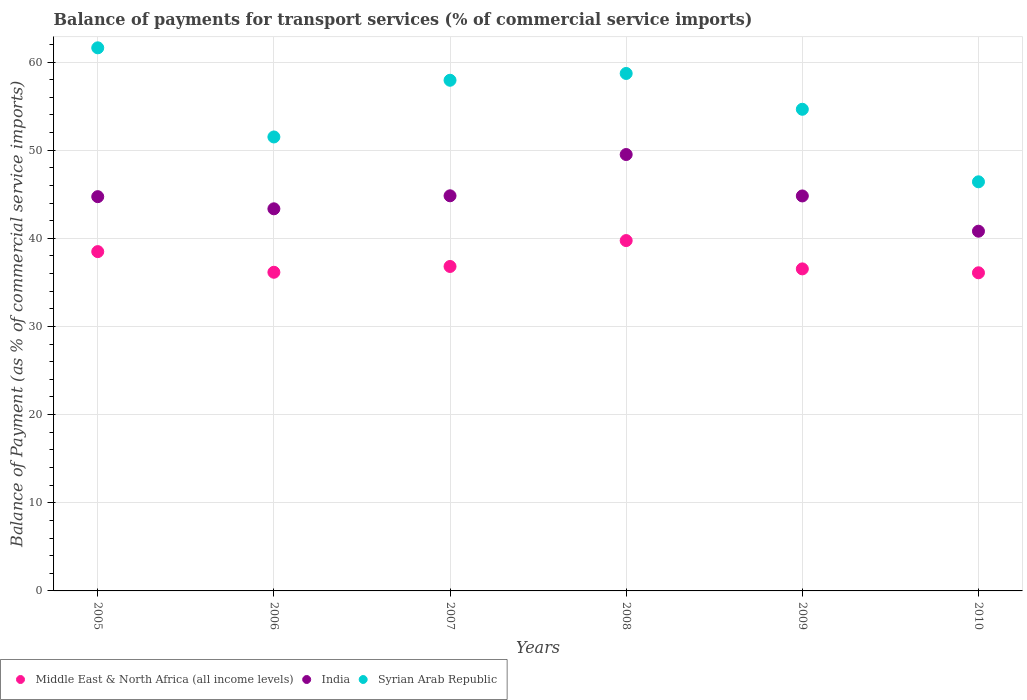How many different coloured dotlines are there?
Offer a terse response. 3. Is the number of dotlines equal to the number of legend labels?
Your answer should be compact. Yes. What is the balance of payments for transport services in Syrian Arab Republic in 2006?
Provide a succinct answer. 51.5. Across all years, what is the maximum balance of payments for transport services in Syrian Arab Republic?
Keep it short and to the point. 61.61. Across all years, what is the minimum balance of payments for transport services in Middle East & North Africa (all income levels)?
Make the answer very short. 36.09. What is the total balance of payments for transport services in India in the graph?
Offer a very short reply. 268.01. What is the difference between the balance of payments for transport services in Syrian Arab Republic in 2007 and that in 2008?
Offer a terse response. -0.77. What is the difference between the balance of payments for transport services in Middle East & North Africa (all income levels) in 2005 and the balance of payments for transport services in Syrian Arab Republic in 2007?
Make the answer very short. -19.44. What is the average balance of payments for transport services in Middle East & North Africa (all income levels) per year?
Offer a very short reply. 37.3. In the year 2005, what is the difference between the balance of payments for transport services in India and balance of payments for transport services in Middle East & North Africa (all income levels)?
Keep it short and to the point. 6.23. What is the ratio of the balance of payments for transport services in India in 2009 to that in 2010?
Ensure brevity in your answer.  1.1. Is the balance of payments for transport services in India in 2008 less than that in 2010?
Provide a short and direct response. No. What is the difference between the highest and the second highest balance of payments for transport services in Syrian Arab Republic?
Give a very brief answer. 2.91. What is the difference between the highest and the lowest balance of payments for transport services in Middle East & North Africa (all income levels)?
Your answer should be very brief. 3.65. In how many years, is the balance of payments for transport services in Syrian Arab Republic greater than the average balance of payments for transport services in Syrian Arab Republic taken over all years?
Keep it short and to the point. 3. Is the sum of the balance of payments for transport services in Middle East & North Africa (all income levels) in 2009 and 2010 greater than the maximum balance of payments for transport services in India across all years?
Your answer should be very brief. Yes. Is the balance of payments for transport services in India strictly greater than the balance of payments for transport services in Middle East & North Africa (all income levels) over the years?
Your response must be concise. Yes. Is the balance of payments for transport services in India strictly less than the balance of payments for transport services in Syrian Arab Republic over the years?
Ensure brevity in your answer.  Yes. How many dotlines are there?
Your answer should be very brief. 3. What is the difference between two consecutive major ticks on the Y-axis?
Your answer should be very brief. 10. Where does the legend appear in the graph?
Give a very brief answer. Bottom left. How many legend labels are there?
Keep it short and to the point. 3. What is the title of the graph?
Give a very brief answer. Balance of payments for transport services (% of commercial service imports). What is the label or title of the Y-axis?
Your answer should be very brief. Balance of Payment (as % of commercial service imports). What is the Balance of Payment (as % of commercial service imports) of Middle East & North Africa (all income levels) in 2005?
Ensure brevity in your answer.  38.49. What is the Balance of Payment (as % of commercial service imports) of India in 2005?
Offer a terse response. 44.73. What is the Balance of Payment (as % of commercial service imports) in Syrian Arab Republic in 2005?
Make the answer very short. 61.61. What is the Balance of Payment (as % of commercial service imports) of Middle East & North Africa (all income levels) in 2006?
Offer a very short reply. 36.15. What is the Balance of Payment (as % of commercial service imports) in India in 2006?
Your answer should be very brief. 43.35. What is the Balance of Payment (as % of commercial service imports) of Syrian Arab Republic in 2006?
Make the answer very short. 51.5. What is the Balance of Payment (as % of commercial service imports) of Middle East & North Africa (all income levels) in 2007?
Make the answer very short. 36.81. What is the Balance of Payment (as % of commercial service imports) in India in 2007?
Your response must be concise. 44.82. What is the Balance of Payment (as % of commercial service imports) of Syrian Arab Republic in 2007?
Your response must be concise. 57.93. What is the Balance of Payment (as % of commercial service imports) of Middle East & North Africa (all income levels) in 2008?
Ensure brevity in your answer.  39.74. What is the Balance of Payment (as % of commercial service imports) in India in 2008?
Keep it short and to the point. 49.51. What is the Balance of Payment (as % of commercial service imports) in Syrian Arab Republic in 2008?
Ensure brevity in your answer.  58.7. What is the Balance of Payment (as % of commercial service imports) in Middle East & North Africa (all income levels) in 2009?
Your response must be concise. 36.53. What is the Balance of Payment (as % of commercial service imports) of India in 2009?
Offer a very short reply. 44.81. What is the Balance of Payment (as % of commercial service imports) in Syrian Arab Republic in 2009?
Keep it short and to the point. 54.64. What is the Balance of Payment (as % of commercial service imports) of Middle East & North Africa (all income levels) in 2010?
Provide a short and direct response. 36.09. What is the Balance of Payment (as % of commercial service imports) of India in 2010?
Offer a terse response. 40.81. What is the Balance of Payment (as % of commercial service imports) of Syrian Arab Republic in 2010?
Make the answer very short. 46.41. Across all years, what is the maximum Balance of Payment (as % of commercial service imports) of Middle East & North Africa (all income levels)?
Keep it short and to the point. 39.74. Across all years, what is the maximum Balance of Payment (as % of commercial service imports) of India?
Your answer should be compact. 49.51. Across all years, what is the maximum Balance of Payment (as % of commercial service imports) in Syrian Arab Republic?
Give a very brief answer. 61.61. Across all years, what is the minimum Balance of Payment (as % of commercial service imports) in Middle East & North Africa (all income levels)?
Provide a short and direct response. 36.09. Across all years, what is the minimum Balance of Payment (as % of commercial service imports) in India?
Your answer should be compact. 40.81. Across all years, what is the minimum Balance of Payment (as % of commercial service imports) in Syrian Arab Republic?
Your response must be concise. 46.41. What is the total Balance of Payment (as % of commercial service imports) of Middle East & North Africa (all income levels) in the graph?
Your response must be concise. 223.81. What is the total Balance of Payment (as % of commercial service imports) in India in the graph?
Your answer should be very brief. 268.01. What is the total Balance of Payment (as % of commercial service imports) in Syrian Arab Republic in the graph?
Keep it short and to the point. 330.79. What is the difference between the Balance of Payment (as % of commercial service imports) of Middle East & North Africa (all income levels) in 2005 and that in 2006?
Your response must be concise. 2.34. What is the difference between the Balance of Payment (as % of commercial service imports) in India in 2005 and that in 2006?
Offer a terse response. 1.38. What is the difference between the Balance of Payment (as % of commercial service imports) in Syrian Arab Republic in 2005 and that in 2006?
Offer a terse response. 10.11. What is the difference between the Balance of Payment (as % of commercial service imports) in Middle East & North Africa (all income levels) in 2005 and that in 2007?
Give a very brief answer. 1.68. What is the difference between the Balance of Payment (as % of commercial service imports) of India in 2005 and that in 2007?
Offer a very short reply. -0.1. What is the difference between the Balance of Payment (as % of commercial service imports) in Syrian Arab Republic in 2005 and that in 2007?
Keep it short and to the point. 3.68. What is the difference between the Balance of Payment (as % of commercial service imports) in Middle East & North Africa (all income levels) in 2005 and that in 2008?
Provide a short and direct response. -1.25. What is the difference between the Balance of Payment (as % of commercial service imports) of India in 2005 and that in 2008?
Your response must be concise. -4.78. What is the difference between the Balance of Payment (as % of commercial service imports) in Syrian Arab Republic in 2005 and that in 2008?
Your answer should be very brief. 2.91. What is the difference between the Balance of Payment (as % of commercial service imports) in Middle East & North Africa (all income levels) in 2005 and that in 2009?
Keep it short and to the point. 1.96. What is the difference between the Balance of Payment (as % of commercial service imports) of India in 2005 and that in 2009?
Give a very brief answer. -0.08. What is the difference between the Balance of Payment (as % of commercial service imports) of Syrian Arab Republic in 2005 and that in 2009?
Give a very brief answer. 6.97. What is the difference between the Balance of Payment (as % of commercial service imports) of Middle East & North Africa (all income levels) in 2005 and that in 2010?
Your response must be concise. 2.4. What is the difference between the Balance of Payment (as % of commercial service imports) in India in 2005 and that in 2010?
Keep it short and to the point. 3.92. What is the difference between the Balance of Payment (as % of commercial service imports) in Syrian Arab Republic in 2005 and that in 2010?
Make the answer very short. 15.2. What is the difference between the Balance of Payment (as % of commercial service imports) in Middle East & North Africa (all income levels) in 2006 and that in 2007?
Keep it short and to the point. -0.66. What is the difference between the Balance of Payment (as % of commercial service imports) of India in 2006 and that in 2007?
Give a very brief answer. -1.48. What is the difference between the Balance of Payment (as % of commercial service imports) of Syrian Arab Republic in 2006 and that in 2007?
Keep it short and to the point. -6.43. What is the difference between the Balance of Payment (as % of commercial service imports) in Middle East & North Africa (all income levels) in 2006 and that in 2008?
Give a very brief answer. -3.6. What is the difference between the Balance of Payment (as % of commercial service imports) of India in 2006 and that in 2008?
Your response must be concise. -6.16. What is the difference between the Balance of Payment (as % of commercial service imports) in Syrian Arab Republic in 2006 and that in 2008?
Give a very brief answer. -7.2. What is the difference between the Balance of Payment (as % of commercial service imports) in Middle East & North Africa (all income levels) in 2006 and that in 2009?
Offer a terse response. -0.38. What is the difference between the Balance of Payment (as % of commercial service imports) of India in 2006 and that in 2009?
Keep it short and to the point. -1.46. What is the difference between the Balance of Payment (as % of commercial service imports) in Syrian Arab Republic in 2006 and that in 2009?
Keep it short and to the point. -3.14. What is the difference between the Balance of Payment (as % of commercial service imports) of Middle East & North Africa (all income levels) in 2006 and that in 2010?
Ensure brevity in your answer.  0.06. What is the difference between the Balance of Payment (as % of commercial service imports) in India in 2006 and that in 2010?
Your answer should be compact. 2.54. What is the difference between the Balance of Payment (as % of commercial service imports) of Syrian Arab Republic in 2006 and that in 2010?
Offer a terse response. 5.09. What is the difference between the Balance of Payment (as % of commercial service imports) in Middle East & North Africa (all income levels) in 2007 and that in 2008?
Provide a short and direct response. -2.94. What is the difference between the Balance of Payment (as % of commercial service imports) in India in 2007 and that in 2008?
Offer a very short reply. -4.68. What is the difference between the Balance of Payment (as % of commercial service imports) of Syrian Arab Republic in 2007 and that in 2008?
Ensure brevity in your answer.  -0.77. What is the difference between the Balance of Payment (as % of commercial service imports) of Middle East & North Africa (all income levels) in 2007 and that in 2009?
Make the answer very short. 0.27. What is the difference between the Balance of Payment (as % of commercial service imports) of India in 2007 and that in 2009?
Your response must be concise. 0.02. What is the difference between the Balance of Payment (as % of commercial service imports) in Syrian Arab Republic in 2007 and that in 2009?
Offer a very short reply. 3.29. What is the difference between the Balance of Payment (as % of commercial service imports) of Middle East & North Africa (all income levels) in 2007 and that in 2010?
Ensure brevity in your answer.  0.72. What is the difference between the Balance of Payment (as % of commercial service imports) of India in 2007 and that in 2010?
Ensure brevity in your answer.  4.02. What is the difference between the Balance of Payment (as % of commercial service imports) of Syrian Arab Republic in 2007 and that in 2010?
Ensure brevity in your answer.  11.52. What is the difference between the Balance of Payment (as % of commercial service imports) of Middle East & North Africa (all income levels) in 2008 and that in 2009?
Provide a short and direct response. 3.21. What is the difference between the Balance of Payment (as % of commercial service imports) of India in 2008 and that in 2009?
Make the answer very short. 4.7. What is the difference between the Balance of Payment (as % of commercial service imports) in Syrian Arab Republic in 2008 and that in 2009?
Make the answer very short. 4.06. What is the difference between the Balance of Payment (as % of commercial service imports) in Middle East & North Africa (all income levels) in 2008 and that in 2010?
Your answer should be very brief. 3.65. What is the difference between the Balance of Payment (as % of commercial service imports) in India in 2008 and that in 2010?
Ensure brevity in your answer.  8.7. What is the difference between the Balance of Payment (as % of commercial service imports) of Syrian Arab Republic in 2008 and that in 2010?
Keep it short and to the point. 12.29. What is the difference between the Balance of Payment (as % of commercial service imports) in Middle East & North Africa (all income levels) in 2009 and that in 2010?
Offer a very short reply. 0.44. What is the difference between the Balance of Payment (as % of commercial service imports) of India in 2009 and that in 2010?
Your response must be concise. 4. What is the difference between the Balance of Payment (as % of commercial service imports) of Syrian Arab Republic in 2009 and that in 2010?
Ensure brevity in your answer.  8.23. What is the difference between the Balance of Payment (as % of commercial service imports) in Middle East & North Africa (all income levels) in 2005 and the Balance of Payment (as % of commercial service imports) in India in 2006?
Offer a terse response. -4.86. What is the difference between the Balance of Payment (as % of commercial service imports) of Middle East & North Africa (all income levels) in 2005 and the Balance of Payment (as % of commercial service imports) of Syrian Arab Republic in 2006?
Give a very brief answer. -13.01. What is the difference between the Balance of Payment (as % of commercial service imports) in India in 2005 and the Balance of Payment (as % of commercial service imports) in Syrian Arab Republic in 2006?
Make the answer very short. -6.77. What is the difference between the Balance of Payment (as % of commercial service imports) of Middle East & North Africa (all income levels) in 2005 and the Balance of Payment (as % of commercial service imports) of India in 2007?
Provide a short and direct response. -6.33. What is the difference between the Balance of Payment (as % of commercial service imports) in Middle East & North Africa (all income levels) in 2005 and the Balance of Payment (as % of commercial service imports) in Syrian Arab Republic in 2007?
Your response must be concise. -19.44. What is the difference between the Balance of Payment (as % of commercial service imports) in India in 2005 and the Balance of Payment (as % of commercial service imports) in Syrian Arab Republic in 2007?
Provide a short and direct response. -13.2. What is the difference between the Balance of Payment (as % of commercial service imports) in Middle East & North Africa (all income levels) in 2005 and the Balance of Payment (as % of commercial service imports) in India in 2008?
Provide a short and direct response. -11.01. What is the difference between the Balance of Payment (as % of commercial service imports) of Middle East & North Africa (all income levels) in 2005 and the Balance of Payment (as % of commercial service imports) of Syrian Arab Republic in 2008?
Provide a succinct answer. -20.21. What is the difference between the Balance of Payment (as % of commercial service imports) in India in 2005 and the Balance of Payment (as % of commercial service imports) in Syrian Arab Republic in 2008?
Provide a short and direct response. -13.98. What is the difference between the Balance of Payment (as % of commercial service imports) of Middle East & North Africa (all income levels) in 2005 and the Balance of Payment (as % of commercial service imports) of India in 2009?
Provide a short and direct response. -6.31. What is the difference between the Balance of Payment (as % of commercial service imports) of Middle East & North Africa (all income levels) in 2005 and the Balance of Payment (as % of commercial service imports) of Syrian Arab Republic in 2009?
Your answer should be compact. -16.15. What is the difference between the Balance of Payment (as % of commercial service imports) in India in 2005 and the Balance of Payment (as % of commercial service imports) in Syrian Arab Republic in 2009?
Keep it short and to the point. -9.91. What is the difference between the Balance of Payment (as % of commercial service imports) in Middle East & North Africa (all income levels) in 2005 and the Balance of Payment (as % of commercial service imports) in India in 2010?
Make the answer very short. -2.32. What is the difference between the Balance of Payment (as % of commercial service imports) of Middle East & North Africa (all income levels) in 2005 and the Balance of Payment (as % of commercial service imports) of Syrian Arab Republic in 2010?
Your answer should be very brief. -7.92. What is the difference between the Balance of Payment (as % of commercial service imports) in India in 2005 and the Balance of Payment (as % of commercial service imports) in Syrian Arab Republic in 2010?
Make the answer very short. -1.68. What is the difference between the Balance of Payment (as % of commercial service imports) in Middle East & North Africa (all income levels) in 2006 and the Balance of Payment (as % of commercial service imports) in India in 2007?
Give a very brief answer. -8.67. What is the difference between the Balance of Payment (as % of commercial service imports) in Middle East & North Africa (all income levels) in 2006 and the Balance of Payment (as % of commercial service imports) in Syrian Arab Republic in 2007?
Offer a very short reply. -21.78. What is the difference between the Balance of Payment (as % of commercial service imports) in India in 2006 and the Balance of Payment (as % of commercial service imports) in Syrian Arab Republic in 2007?
Make the answer very short. -14.58. What is the difference between the Balance of Payment (as % of commercial service imports) in Middle East & North Africa (all income levels) in 2006 and the Balance of Payment (as % of commercial service imports) in India in 2008?
Provide a succinct answer. -13.36. What is the difference between the Balance of Payment (as % of commercial service imports) of Middle East & North Africa (all income levels) in 2006 and the Balance of Payment (as % of commercial service imports) of Syrian Arab Republic in 2008?
Your response must be concise. -22.55. What is the difference between the Balance of Payment (as % of commercial service imports) in India in 2006 and the Balance of Payment (as % of commercial service imports) in Syrian Arab Republic in 2008?
Ensure brevity in your answer.  -15.35. What is the difference between the Balance of Payment (as % of commercial service imports) of Middle East & North Africa (all income levels) in 2006 and the Balance of Payment (as % of commercial service imports) of India in 2009?
Keep it short and to the point. -8.66. What is the difference between the Balance of Payment (as % of commercial service imports) in Middle East & North Africa (all income levels) in 2006 and the Balance of Payment (as % of commercial service imports) in Syrian Arab Republic in 2009?
Make the answer very short. -18.49. What is the difference between the Balance of Payment (as % of commercial service imports) of India in 2006 and the Balance of Payment (as % of commercial service imports) of Syrian Arab Republic in 2009?
Make the answer very short. -11.29. What is the difference between the Balance of Payment (as % of commercial service imports) in Middle East & North Africa (all income levels) in 2006 and the Balance of Payment (as % of commercial service imports) in India in 2010?
Keep it short and to the point. -4.66. What is the difference between the Balance of Payment (as % of commercial service imports) of Middle East & North Africa (all income levels) in 2006 and the Balance of Payment (as % of commercial service imports) of Syrian Arab Republic in 2010?
Make the answer very short. -10.26. What is the difference between the Balance of Payment (as % of commercial service imports) in India in 2006 and the Balance of Payment (as % of commercial service imports) in Syrian Arab Republic in 2010?
Your response must be concise. -3.06. What is the difference between the Balance of Payment (as % of commercial service imports) of Middle East & North Africa (all income levels) in 2007 and the Balance of Payment (as % of commercial service imports) of India in 2008?
Ensure brevity in your answer.  -12.7. What is the difference between the Balance of Payment (as % of commercial service imports) in Middle East & North Africa (all income levels) in 2007 and the Balance of Payment (as % of commercial service imports) in Syrian Arab Republic in 2008?
Provide a succinct answer. -21.89. What is the difference between the Balance of Payment (as % of commercial service imports) in India in 2007 and the Balance of Payment (as % of commercial service imports) in Syrian Arab Republic in 2008?
Make the answer very short. -13.88. What is the difference between the Balance of Payment (as % of commercial service imports) of Middle East & North Africa (all income levels) in 2007 and the Balance of Payment (as % of commercial service imports) of India in 2009?
Give a very brief answer. -8. What is the difference between the Balance of Payment (as % of commercial service imports) in Middle East & North Africa (all income levels) in 2007 and the Balance of Payment (as % of commercial service imports) in Syrian Arab Republic in 2009?
Provide a short and direct response. -17.83. What is the difference between the Balance of Payment (as % of commercial service imports) in India in 2007 and the Balance of Payment (as % of commercial service imports) in Syrian Arab Republic in 2009?
Make the answer very short. -9.82. What is the difference between the Balance of Payment (as % of commercial service imports) of Middle East & North Africa (all income levels) in 2007 and the Balance of Payment (as % of commercial service imports) of India in 2010?
Your answer should be compact. -4. What is the difference between the Balance of Payment (as % of commercial service imports) of Middle East & North Africa (all income levels) in 2007 and the Balance of Payment (as % of commercial service imports) of Syrian Arab Republic in 2010?
Ensure brevity in your answer.  -9.6. What is the difference between the Balance of Payment (as % of commercial service imports) in India in 2007 and the Balance of Payment (as % of commercial service imports) in Syrian Arab Republic in 2010?
Offer a terse response. -1.59. What is the difference between the Balance of Payment (as % of commercial service imports) in Middle East & North Africa (all income levels) in 2008 and the Balance of Payment (as % of commercial service imports) in India in 2009?
Your answer should be compact. -5.06. What is the difference between the Balance of Payment (as % of commercial service imports) of Middle East & North Africa (all income levels) in 2008 and the Balance of Payment (as % of commercial service imports) of Syrian Arab Republic in 2009?
Offer a terse response. -14.89. What is the difference between the Balance of Payment (as % of commercial service imports) in India in 2008 and the Balance of Payment (as % of commercial service imports) in Syrian Arab Republic in 2009?
Your answer should be very brief. -5.13. What is the difference between the Balance of Payment (as % of commercial service imports) of Middle East & North Africa (all income levels) in 2008 and the Balance of Payment (as % of commercial service imports) of India in 2010?
Ensure brevity in your answer.  -1.06. What is the difference between the Balance of Payment (as % of commercial service imports) of Middle East & North Africa (all income levels) in 2008 and the Balance of Payment (as % of commercial service imports) of Syrian Arab Republic in 2010?
Provide a short and direct response. -6.67. What is the difference between the Balance of Payment (as % of commercial service imports) in India in 2008 and the Balance of Payment (as % of commercial service imports) in Syrian Arab Republic in 2010?
Offer a terse response. 3.1. What is the difference between the Balance of Payment (as % of commercial service imports) in Middle East & North Africa (all income levels) in 2009 and the Balance of Payment (as % of commercial service imports) in India in 2010?
Your response must be concise. -4.28. What is the difference between the Balance of Payment (as % of commercial service imports) of Middle East & North Africa (all income levels) in 2009 and the Balance of Payment (as % of commercial service imports) of Syrian Arab Republic in 2010?
Provide a short and direct response. -9.88. What is the difference between the Balance of Payment (as % of commercial service imports) of India in 2009 and the Balance of Payment (as % of commercial service imports) of Syrian Arab Republic in 2010?
Your answer should be compact. -1.6. What is the average Balance of Payment (as % of commercial service imports) in Middle East & North Africa (all income levels) per year?
Offer a very short reply. 37.3. What is the average Balance of Payment (as % of commercial service imports) in India per year?
Make the answer very short. 44.67. What is the average Balance of Payment (as % of commercial service imports) in Syrian Arab Republic per year?
Your answer should be very brief. 55.13. In the year 2005, what is the difference between the Balance of Payment (as % of commercial service imports) in Middle East & North Africa (all income levels) and Balance of Payment (as % of commercial service imports) in India?
Give a very brief answer. -6.23. In the year 2005, what is the difference between the Balance of Payment (as % of commercial service imports) in Middle East & North Africa (all income levels) and Balance of Payment (as % of commercial service imports) in Syrian Arab Republic?
Provide a short and direct response. -23.12. In the year 2005, what is the difference between the Balance of Payment (as % of commercial service imports) in India and Balance of Payment (as % of commercial service imports) in Syrian Arab Republic?
Your answer should be compact. -16.88. In the year 2006, what is the difference between the Balance of Payment (as % of commercial service imports) in Middle East & North Africa (all income levels) and Balance of Payment (as % of commercial service imports) in India?
Provide a short and direct response. -7.2. In the year 2006, what is the difference between the Balance of Payment (as % of commercial service imports) in Middle East & North Africa (all income levels) and Balance of Payment (as % of commercial service imports) in Syrian Arab Republic?
Provide a succinct answer. -15.35. In the year 2006, what is the difference between the Balance of Payment (as % of commercial service imports) in India and Balance of Payment (as % of commercial service imports) in Syrian Arab Republic?
Provide a succinct answer. -8.15. In the year 2007, what is the difference between the Balance of Payment (as % of commercial service imports) of Middle East & North Africa (all income levels) and Balance of Payment (as % of commercial service imports) of India?
Ensure brevity in your answer.  -8.02. In the year 2007, what is the difference between the Balance of Payment (as % of commercial service imports) of Middle East & North Africa (all income levels) and Balance of Payment (as % of commercial service imports) of Syrian Arab Republic?
Give a very brief answer. -21.12. In the year 2007, what is the difference between the Balance of Payment (as % of commercial service imports) of India and Balance of Payment (as % of commercial service imports) of Syrian Arab Republic?
Ensure brevity in your answer.  -13.11. In the year 2008, what is the difference between the Balance of Payment (as % of commercial service imports) in Middle East & North Africa (all income levels) and Balance of Payment (as % of commercial service imports) in India?
Offer a terse response. -9.76. In the year 2008, what is the difference between the Balance of Payment (as % of commercial service imports) of Middle East & North Africa (all income levels) and Balance of Payment (as % of commercial service imports) of Syrian Arab Republic?
Offer a terse response. -18.96. In the year 2008, what is the difference between the Balance of Payment (as % of commercial service imports) of India and Balance of Payment (as % of commercial service imports) of Syrian Arab Republic?
Your answer should be very brief. -9.2. In the year 2009, what is the difference between the Balance of Payment (as % of commercial service imports) of Middle East & North Africa (all income levels) and Balance of Payment (as % of commercial service imports) of India?
Your answer should be compact. -8.27. In the year 2009, what is the difference between the Balance of Payment (as % of commercial service imports) of Middle East & North Africa (all income levels) and Balance of Payment (as % of commercial service imports) of Syrian Arab Republic?
Offer a very short reply. -18.11. In the year 2009, what is the difference between the Balance of Payment (as % of commercial service imports) in India and Balance of Payment (as % of commercial service imports) in Syrian Arab Republic?
Provide a short and direct response. -9.83. In the year 2010, what is the difference between the Balance of Payment (as % of commercial service imports) in Middle East & North Africa (all income levels) and Balance of Payment (as % of commercial service imports) in India?
Provide a short and direct response. -4.72. In the year 2010, what is the difference between the Balance of Payment (as % of commercial service imports) in Middle East & North Africa (all income levels) and Balance of Payment (as % of commercial service imports) in Syrian Arab Republic?
Provide a succinct answer. -10.32. In the year 2010, what is the difference between the Balance of Payment (as % of commercial service imports) of India and Balance of Payment (as % of commercial service imports) of Syrian Arab Republic?
Your answer should be very brief. -5.6. What is the ratio of the Balance of Payment (as % of commercial service imports) in Middle East & North Africa (all income levels) in 2005 to that in 2006?
Provide a succinct answer. 1.06. What is the ratio of the Balance of Payment (as % of commercial service imports) in India in 2005 to that in 2006?
Your response must be concise. 1.03. What is the ratio of the Balance of Payment (as % of commercial service imports) in Syrian Arab Republic in 2005 to that in 2006?
Provide a succinct answer. 1.2. What is the ratio of the Balance of Payment (as % of commercial service imports) of Middle East & North Africa (all income levels) in 2005 to that in 2007?
Offer a very short reply. 1.05. What is the ratio of the Balance of Payment (as % of commercial service imports) in Syrian Arab Republic in 2005 to that in 2007?
Your answer should be compact. 1.06. What is the ratio of the Balance of Payment (as % of commercial service imports) of Middle East & North Africa (all income levels) in 2005 to that in 2008?
Offer a very short reply. 0.97. What is the ratio of the Balance of Payment (as % of commercial service imports) in India in 2005 to that in 2008?
Your response must be concise. 0.9. What is the ratio of the Balance of Payment (as % of commercial service imports) of Syrian Arab Republic in 2005 to that in 2008?
Provide a succinct answer. 1.05. What is the ratio of the Balance of Payment (as % of commercial service imports) of Middle East & North Africa (all income levels) in 2005 to that in 2009?
Your answer should be compact. 1.05. What is the ratio of the Balance of Payment (as % of commercial service imports) of India in 2005 to that in 2009?
Offer a terse response. 1. What is the ratio of the Balance of Payment (as % of commercial service imports) of Syrian Arab Republic in 2005 to that in 2009?
Give a very brief answer. 1.13. What is the ratio of the Balance of Payment (as % of commercial service imports) of Middle East & North Africa (all income levels) in 2005 to that in 2010?
Offer a terse response. 1.07. What is the ratio of the Balance of Payment (as % of commercial service imports) in India in 2005 to that in 2010?
Give a very brief answer. 1.1. What is the ratio of the Balance of Payment (as % of commercial service imports) in Syrian Arab Republic in 2005 to that in 2010?
Your answer should be very brief. 1.33. What is the ratio of the Balance of Payment (as % of commercial service imports) in Middle East & North Africa (all income levels) in 2006 to that in 2007?
Your response must be concise. 0.98. What is the ratio of the Balance of Payment (as % of commercial service imports) of India in 2006 to that in 2007?
Your answer should be compact. 0.97. What is the ratio of the Balance of Payment (as % of commercial service imports) in Syrian Arab Republic in 2006 to that in 2007?
Make the answer very short. 0.89. What is the ratio of the Balance of Payment (as % of commercial service imports) of Middle East & North Africa (all income levels) in 2006 to that in 2008?
Offer a terse response. 0.91. What is the ratio of the Balance of Payment (as % of commercial service imports) of India in 2006 to that in 2008?
Offer a very short reply. 0.88. What is the ratio of the Balance of Payment (as % of commercial service imports) in Syrian Arab Republic in 2006 to that in 2008?
Provide a succinct answer. 0.88. What is the ratio of the Balance of Payment (as % of commercial service imports) in India in 2006 to that in 2009?
Offer a very short reply. 0.97. What is the ratio of the Balance of Payment (as % of commercial service imports) in Syrian Arab Republic in 2006 to that in 2009?
Offer a terse response. 0.94. What is the ratio of the Balance of Payment (as % of commercial service imports) of India in 2006 to that in 2010?
Provide a short and direct response. 1.06. What is the ratio of the Balance of Payment (as % of commercial service imports) of Syrian Arab Republic in 2006 to that in 2010?
Your answer should be very brief. 1.11. What is the ratio of the Balance of Payment (as % of commercial service imports) of Middle East & North Africa (all income levels) in 2007 to that in 2008?
Offer a very short reply. 0.93. What is the ratio of the Balance of Payment (as % of commercial service imports) in India in 2007 to that in 2008?
Your answer should be compact. 0.91. What is the ratio of the Balance of Payment (as % of commercial service imports) in Syrian Arab Republic in 2007 to that in 2008?
Provide a short and direct response. 0.99. What is the ratio of the Balance of Payment (as % of commercial service imports) of Middle East & North Africa (all income levels) in 2007 to that in 2009?
Provide a short and direct response. 1.01. What is the ratio of the Balance of Payment (as % of commercial service imports) in Syrian Arab Republic in 2007 to that in 2009?
Offer a very short reply. 1.06. What is the ratio of the Balance of Payment (as % of commercial service imports) in Middle East & North Africa (all income levels) in 2007 to that in 2010?
Provide a short and direct response. 1.02. What is the ratio of the Balance of Payment (as % of commercial service imports) of India in 2007 to that in 2010?
Provide a short and direct response. 1.1. What is the ratio of the Balance of Payment (as % of commercial service imports) in Syrian Arab Republic in 2007 to that in 2010?
Your response must be concise. 1.25. What is the ratio of the Balance of Payment (as % of commercial service imports) in Middle East & North Africa (all income levels) in 2008 to that in 2009?
Ensure brevity in your answer.  1.09. What is the ratio of the Balance of Payment (as % of commercial service imports) in India in 2008 to that in 2009?
Your answer should be very brief. 1.1. What is the ratio of the Balance of Payment (as % of commercial service imports) of Syrian Arab Republic in 2008 to that in 2009?
Ensure brevity in your answer.  1.07. What is the ratio of the Balance of Payment (as % of commercial service imports) in Middle East & North Africa (all income levels) in 2008 to that in 2010?
Offer a terse response. 1.1. What is the ratio of the Balance of Payment (as % of commercial service imports) of India in 2008 to that in 2010?
Your answer should be very brief. 1.21. What is the ratio of the Balance of Payment (as % of commercial service imports) of Syrian Arab Republic in 2008 to that in 2010?
Ensure brevity in your answer.  1.26. What is the ratio of the Balance of Payment (as % of commercial service imports) in Middle East & North Africa (all income levels) in 2009 to that in 2010?
Offer a terse response. 1.01. What is the ratio of the Balance of Payment (as % of commercial service imports) of India in 2009 to that in 2010?
Keep it short and to the point. 1.1. What is the ratio of the Balance of Payment (as % of commercial service imports) in Syrian Arab Republic in 2009 to that in 2010?
Make the answer very short. 1.18. What is the difference between the highest and the second highest Balance of Payment (as % of commercial service imports) in Middle East & North Africa (all income levels)?
Offer a terse response. 1.25. What is the difference between the highest and the second highest Balance of Payment (as % of commercial service imports) in India?
Provide a succinct answer. 4.68. What is the difference between the highest and the second highest Balance of Payment (as % of commercial service imports) in Syrian Arab Republic?
Offer a very short reply. 2.91. What is the difference between the highest and the lowest Balance of Payment (as % of commercial service imports) in Middle East & North Africa (all income levels)?
Offer a very short reply. 3.65. What is the difference between the highest and the lowest Balance of Payment (as % of commercial service imports) in India?
Your answer should be compact. 8.7. What is the difference between the highest and the lowest Balance of Payment (as % of commercial service imports) of Syrian Arab Republic?
Make the answer very short. 15.2. 